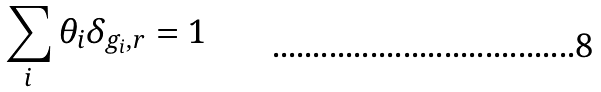<formula> <loc_0><loc_0><loc_500><loc_500>\sum _ { i } \theta _ { i } \delta _ { g _ { i } , r } = 1</formula> 